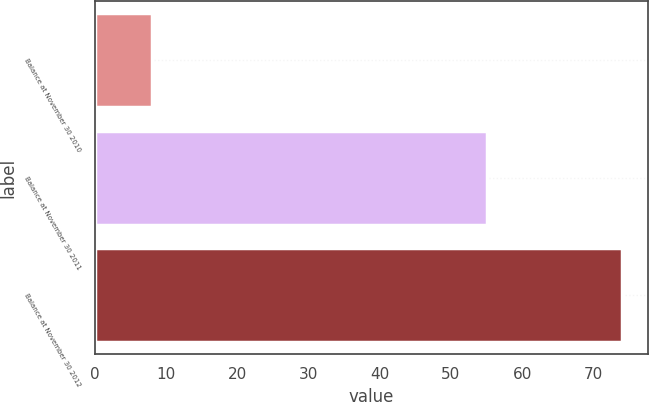Convert chart to OTSL. <chart><loc_0><loc_0><loc_500><loc_500><bar_chart><fcel>Balance at November 30 2010<fcel>Balance at November 30 2011<fcel>Balance at November 30 2012<nl><fcel>8<fcel>55<fcel>74<nl></chart> 